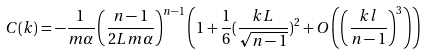<formula> <loc_0><loc_0><loc_500><loc_500>C ( k ) = - \frac { 1 } { m \alpha } \left ( \frac { n - 1 } { 2 L m \alpha } \right ) ^ { n - 1 } \left ( 1 + \frac { 1 } { 6 } ( \frac { k L } { \sqrt { n - 1 } } ) ^ { 2 } + O \left ( \left ( \frac { k l } { n - 1 } \right ) ^ { 3 } \right ) \right )</formula> 